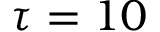<formula> <loc_0><loc_0><loc_500><loc_500>\tau = 1 0</formula> 